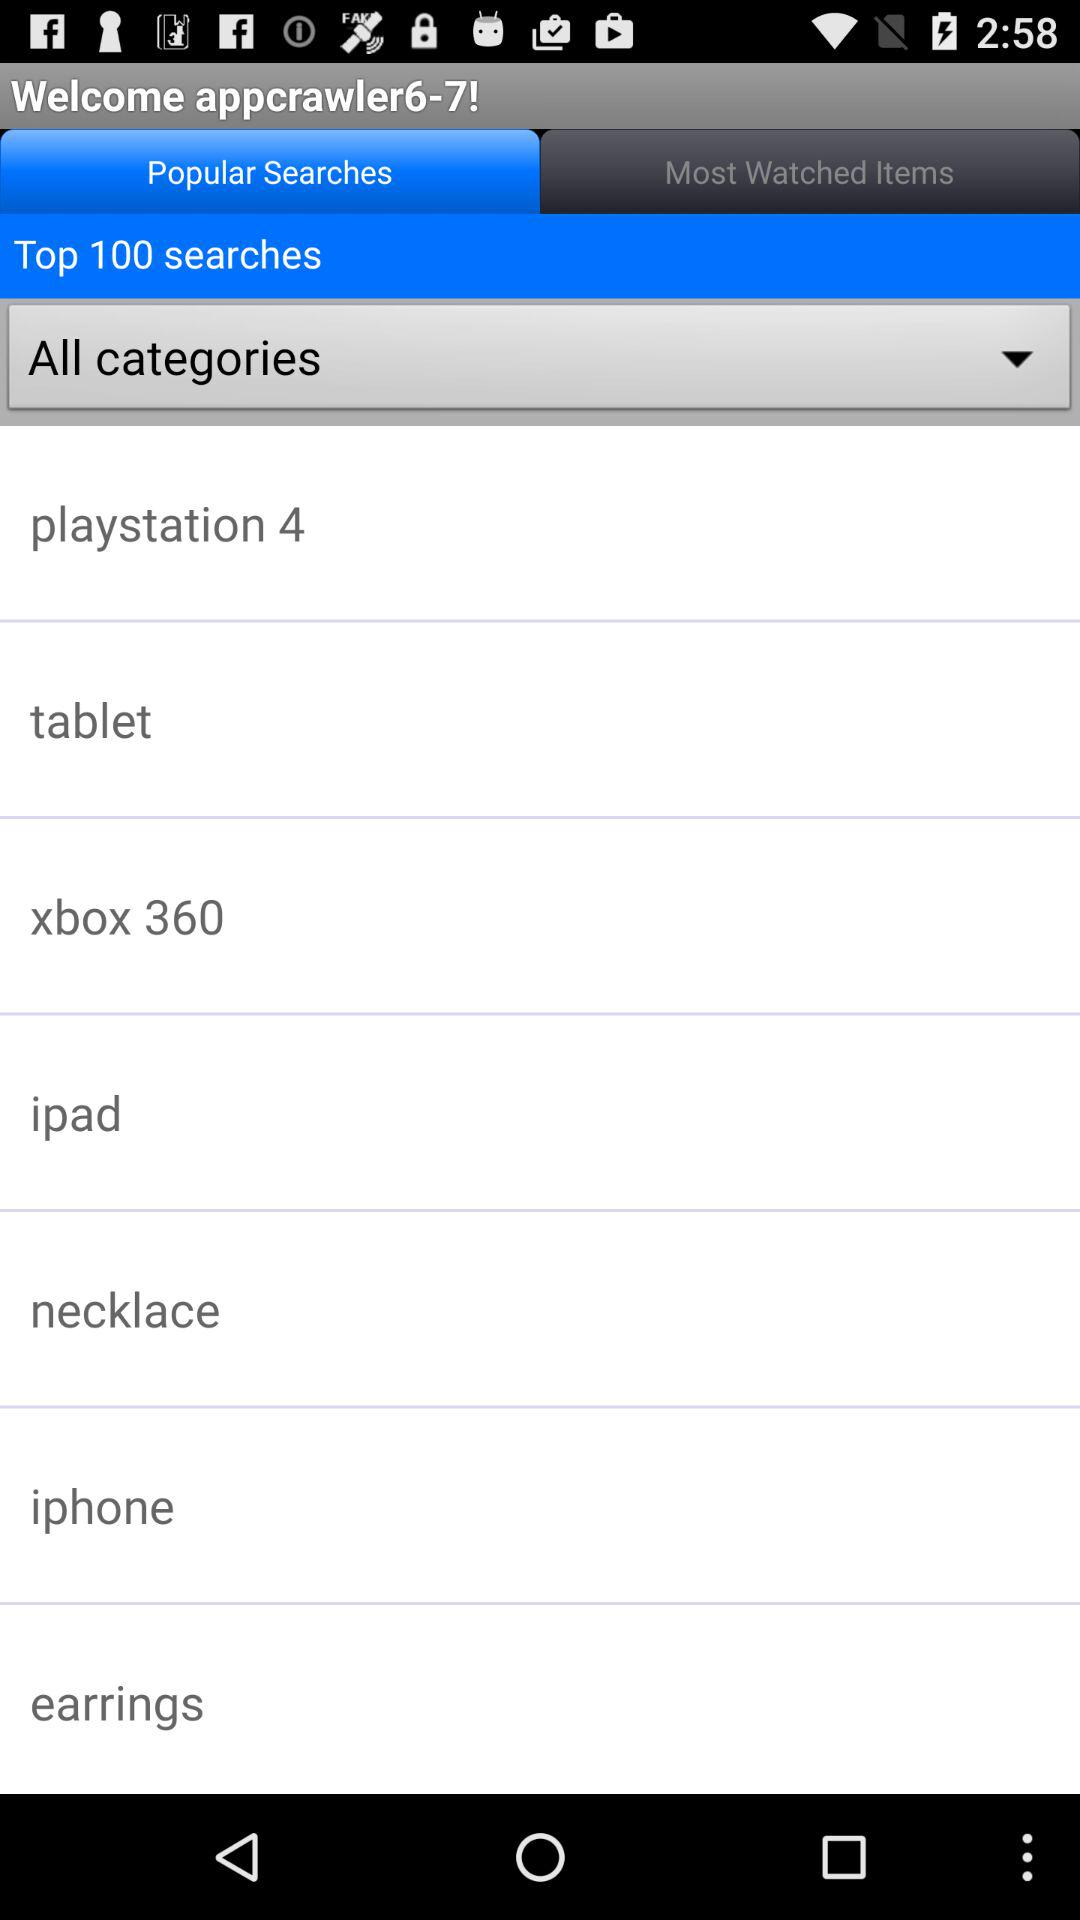Which tab is selected? The selected tab is "Popular Searches ". 